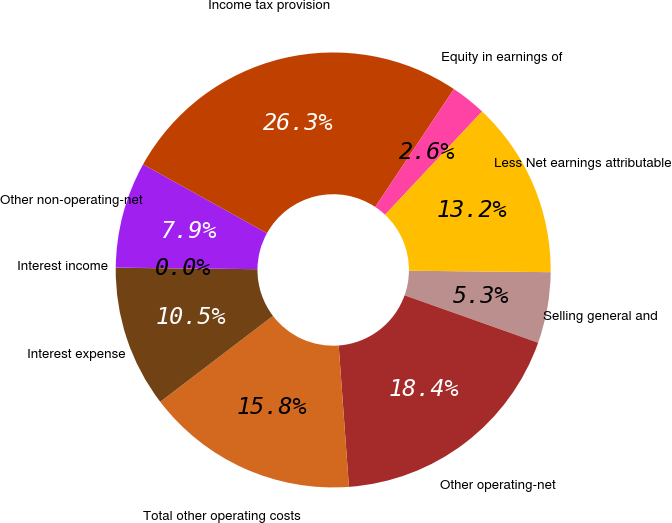<chart> <loc_0><loc_0><loc_500><loc_500><pie_chart><fcel>Selling general and<fcel>Other operating-net<fcel>Total other operating costs<fcel>Interest expense<fcel>Interest income<fcel>Other non-operating-net<fcel>Income tax provision<fcel>Equity in earnings of<fcel>Less Net earnings attributable<nl><fcel>5.27%<fcel>18.42%<fcel>15.79%<fcel>10.53%<fcel>0.01%<fcel>7.9%<fcel>26.3%<fcel>2.64%<fcel>13.16%<nl></chart> 